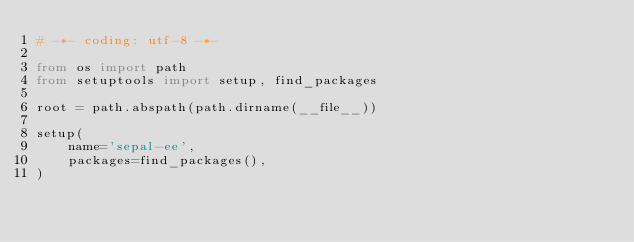Convert code to text. <code><loc_0><loc_0><loc_500><loc_500><_Python_># -*- coding: utf-8 -*-

from os import path
from setuptools import setup, find_packages

root = path.abspath(path.dirname(__file__))

setup(
    name='sepal-ee',
    packages=find_packages(),
)</code> 